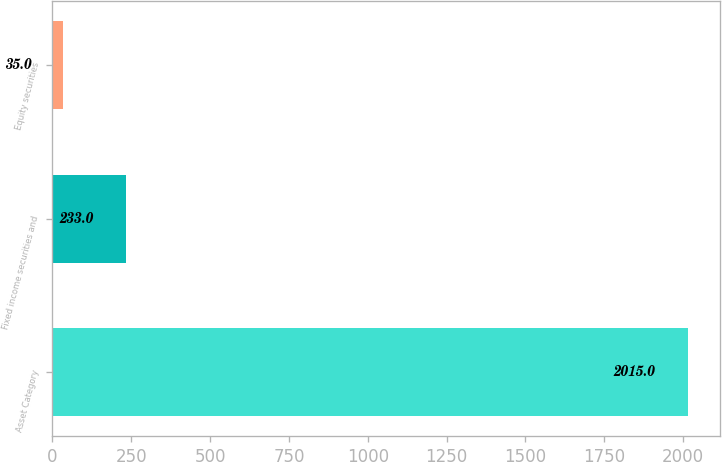<chart> <loc_0><loc_0><loc_500><loc_500><bar_chart><fcel>Asset Category<fcel>Fixed income securities and<fcel>Equity securities<nl><fcel>2015<fcel>233<fcel>35<nl></chart> 